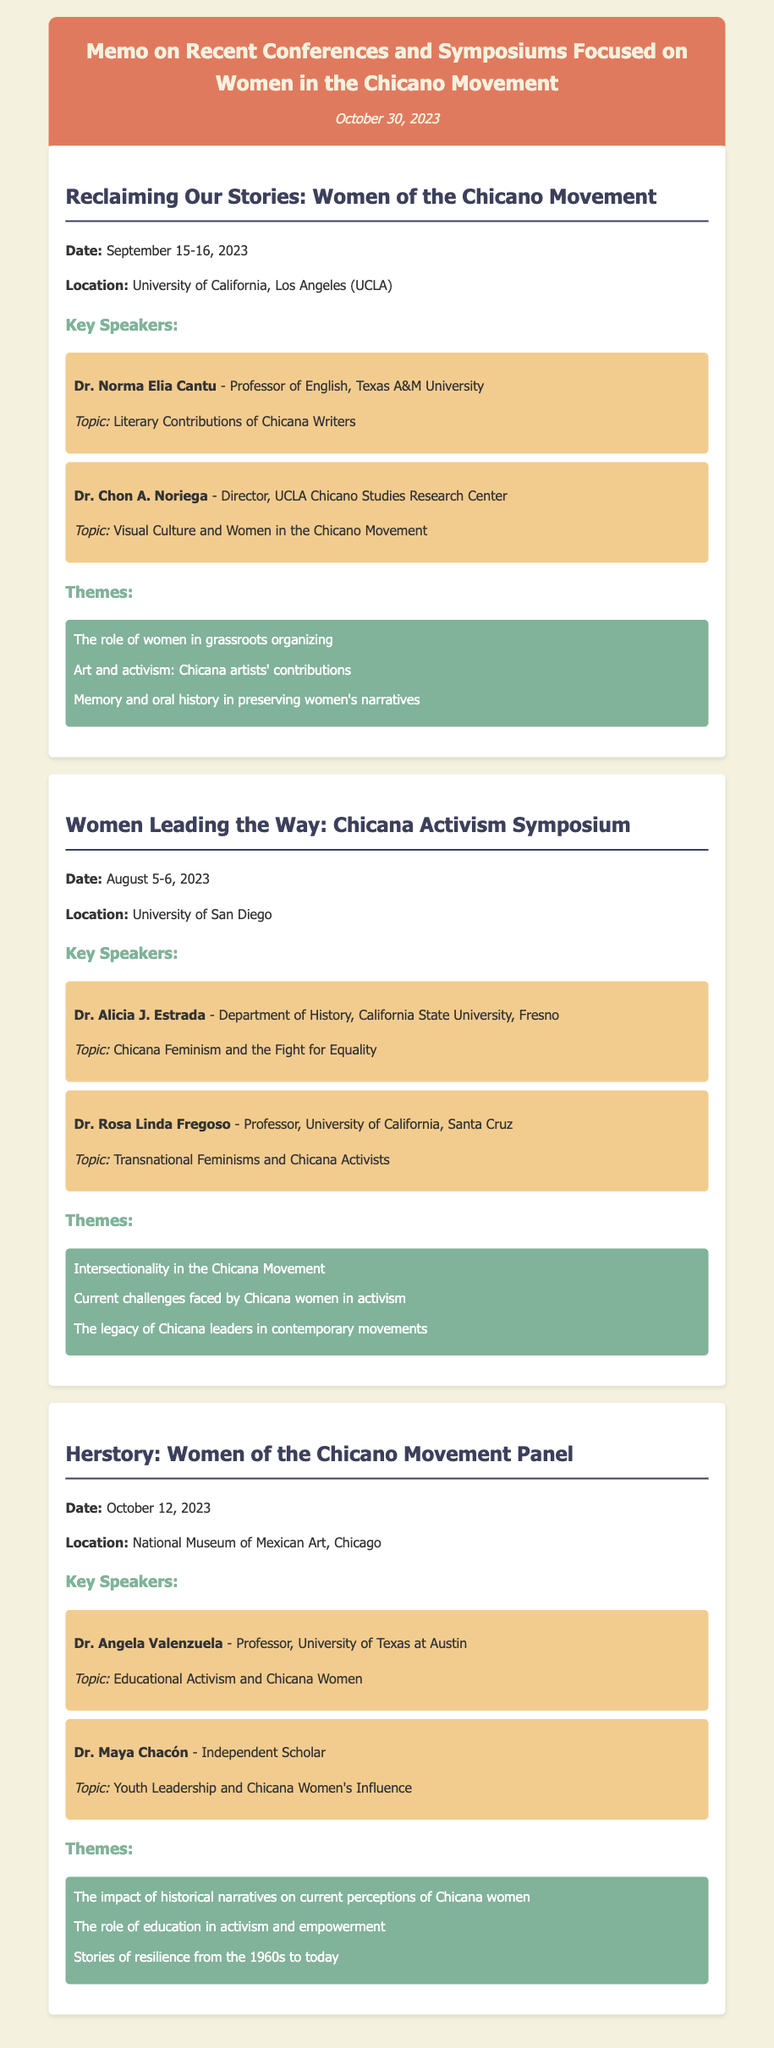What was the date of the "Reclaiming Our Stories" conference? The date is mentioned in the memo, which states it occurred on September 15-16, 2023.
Answer: September 15-16, 2023 Who was the speaker at the "Women Leading the Way" symposium discussing Chicana Feminism? The speaker who discussed Chicana Feminism is Dr. Alicia J. Estrada, as stated in the memo.
Answer: Dr. Alicia J. Estrada What was one of the themes discussed at the "Herstory" panel? The themes listed for the Herstory panel includes multiple items, one being the impact of historical narratives on current perceptions of Chicana women.
Answer: The impact of historical narratives on current perceptions of Chicana women Which location hosted the "Women Leading the Way" symposium? The location for this event is given in the memo as the University of San Diego.
Answer: University of San Diego Who discussed Visual Culture and Women in the Chicano Movement? The relevant information indicates that Dr. Chon A. Noriega covered this topic in his presentation.
Answer: Dr. Chon A. Noriega What was a key theme of the "Reclaiming Our Stories" conference? From the document, one theme is the role of women in grassroots organizing, highlighting an important aspect of the conference.
Answer: The role of women in grassroots organizing What organization is Dr. Rosa Linda Fregoso associated with? The memo details that she is a professor at the University of California, Santa Cruz.
Answer: University of California, Santa Cruz How many conferences are detailed in the memo? The memo lists three separate conferences and symposiums focused on women in the Chicano Movement.
Answer: Three 